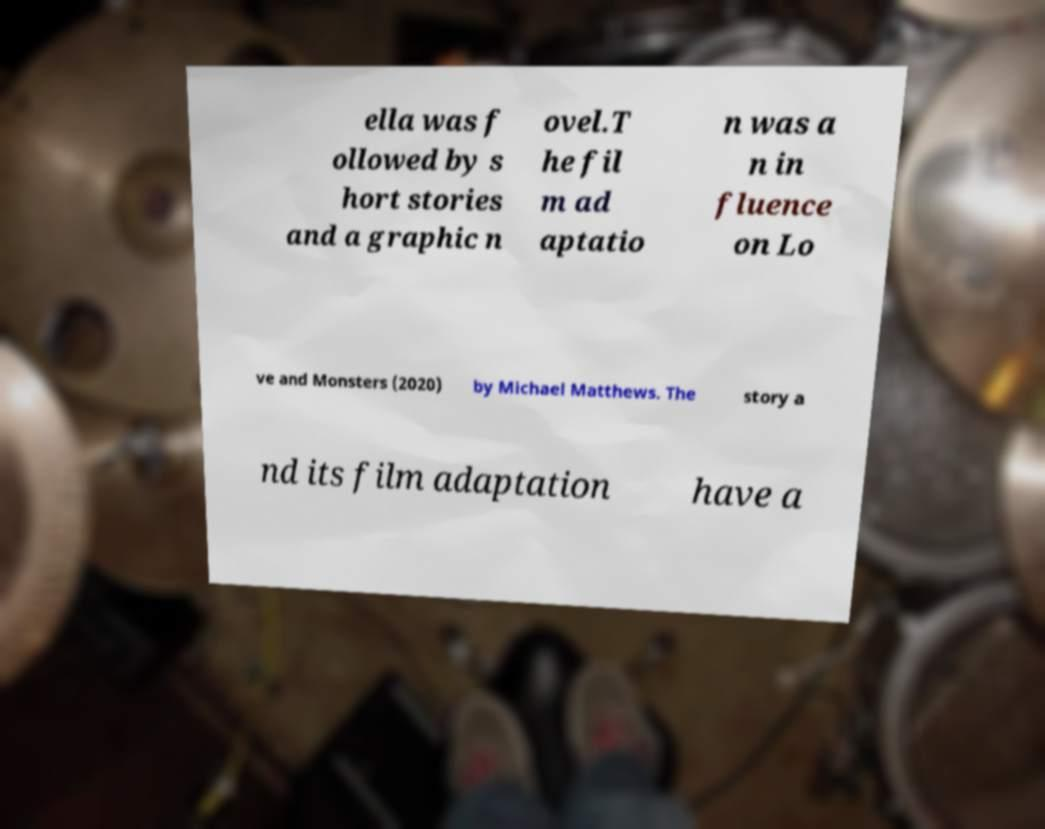Could you assist in decoding the text presented in this image and type it out clearly? ella was f ollowed by s hort stories and a graphic n ovel.T he fil m ad aptatio n was a n in fluence on Lo ve and Monsters (2020) by Michael Matthews. The story a nd its film adaptation have a 